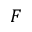Convert formula to latex. <formula><loc_0><loc_0><loc_500><loc_500>F</formula> 